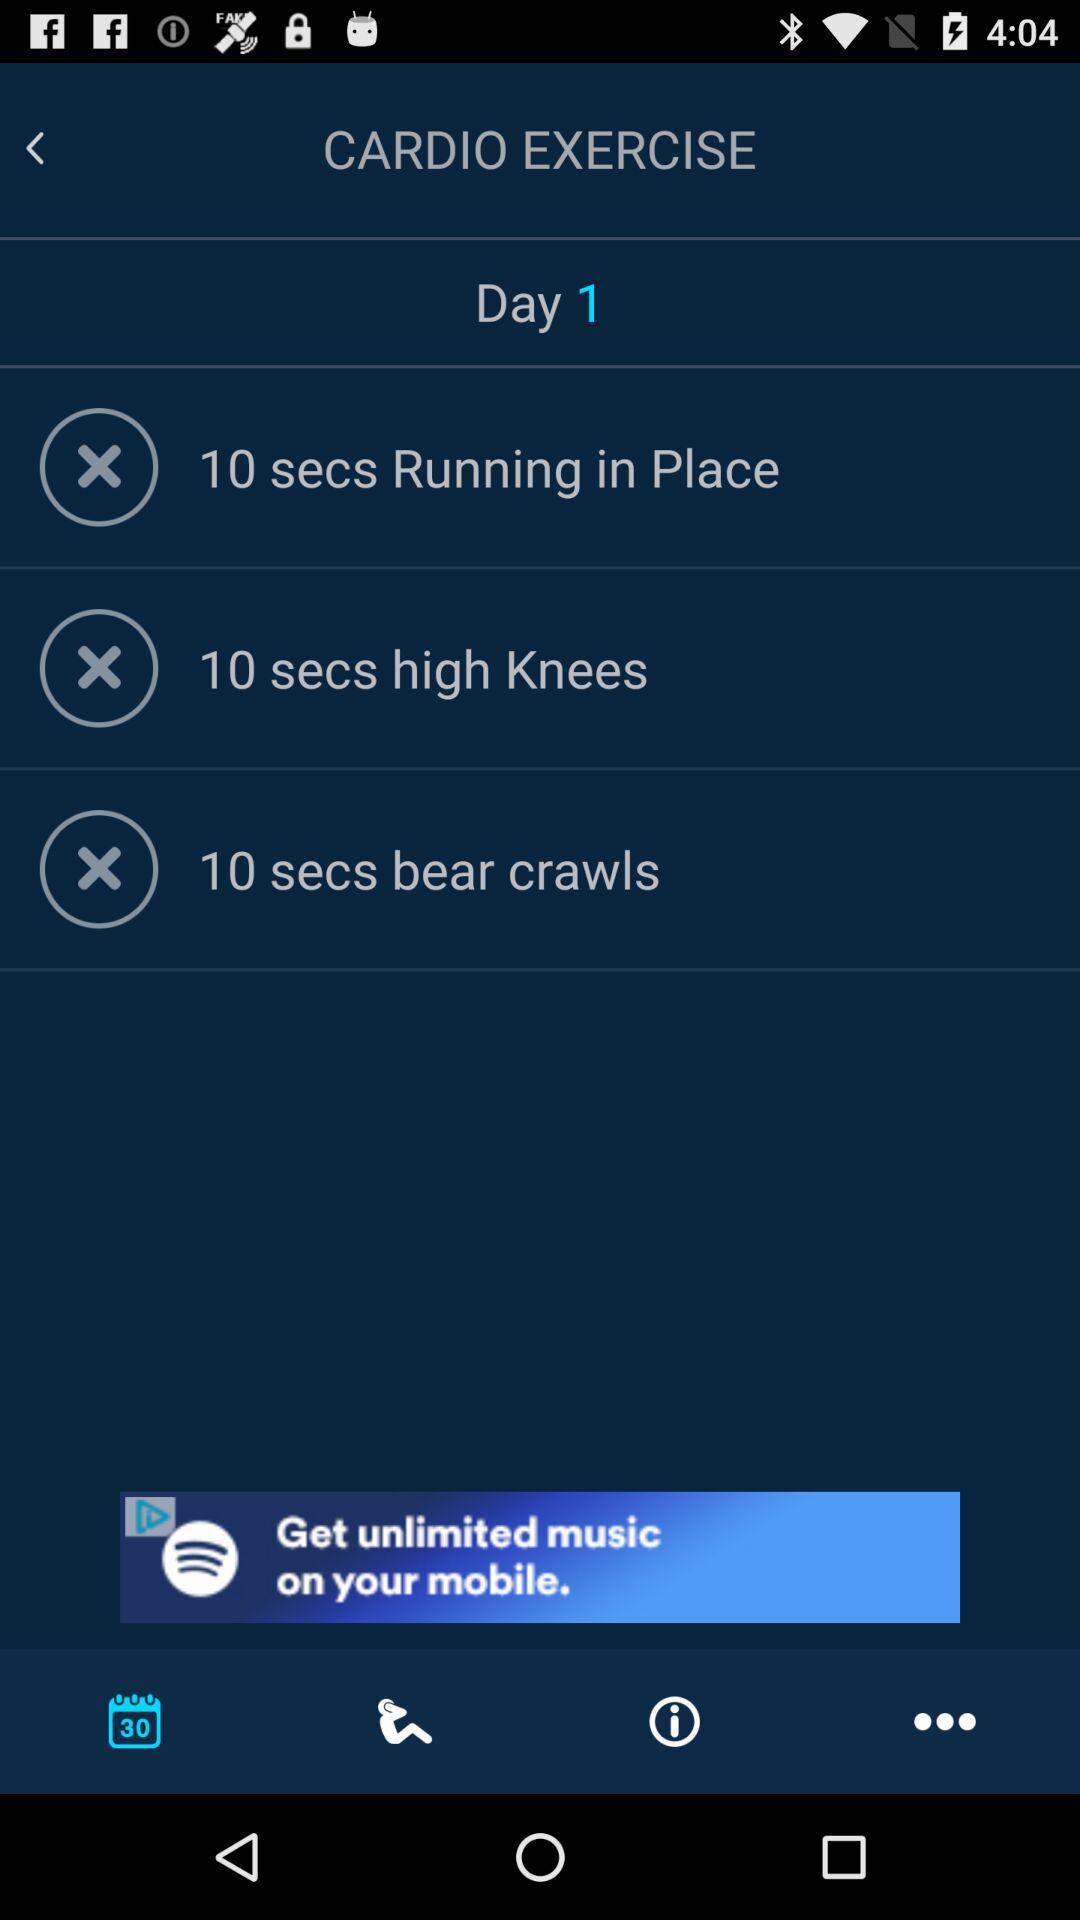How many exercise items are in this workout?
Answer the question using a single word or phrase. 3 